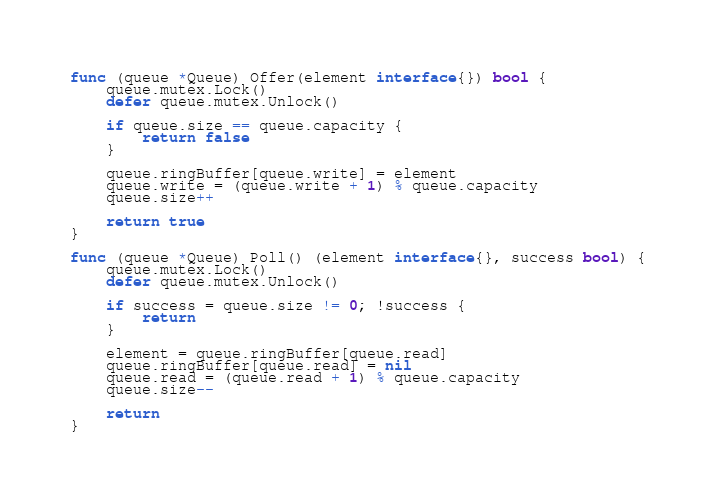Convert code to text. <code><loc_0><loc_0><loc_500><loc_500><_Go_>func (queue *Queue) Offer(element interface{}) bool {
	queue.mutex.Lock()
	defer queue.mutex.Unlock()

	if queue.size == queue.capacity {
		return false
	}

	queue.ringBuffer[queue.write] = element
	queue.write = (queue.write + 1) % queue.capacity
	queue.size++

	return true
}

func (queue *Queue) Poll() (element interface{}, success bool) {
	queue.mutex.Lock()
	defer queue.mutex.Unlock()

	if success = queue.size != 0; !success {
		return
	}

	element = queue.ringBuffer[queue.read]
	queue.ringBuffer[queue.read] = nil
	queue.read = (queue.read + 1) % queue.capacity
	queue.size--

	return
}
</code> 